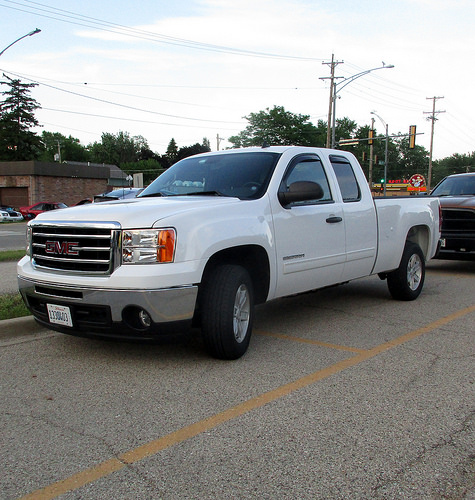<image>
Is there a tire on the car? No. The tire is not positioned on the car. They may be near each other, but the tire is not supported by or resting on top of the car. Is there a house to the right of the car? Yes. From this viewpoint, the house is positioned to the right side relative to the car. Is there a car in the road? Yes. The car is contained within or inside the road, showing a containment relationship. 